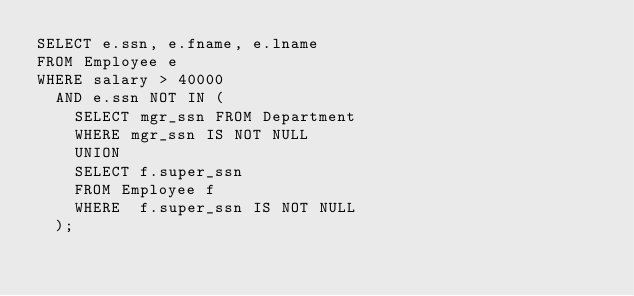Convert code to text. <code><loc_0><loc_0><loc_500><loc_500><_SQL_>SELECT e.ssn, e.fname, e.lname
FROM Employee e
WHERE salary > 40000
  AND e.ssn NOT IN (
    SELECT mgr_ssn FROM Department
    WHERE mgr_ssn IS NOT NULL
    UNION
    SELECT f.super_ssn
    FROM Employee f
    WHERE  f.super_ssn IS NOT NULL
  );</code> 